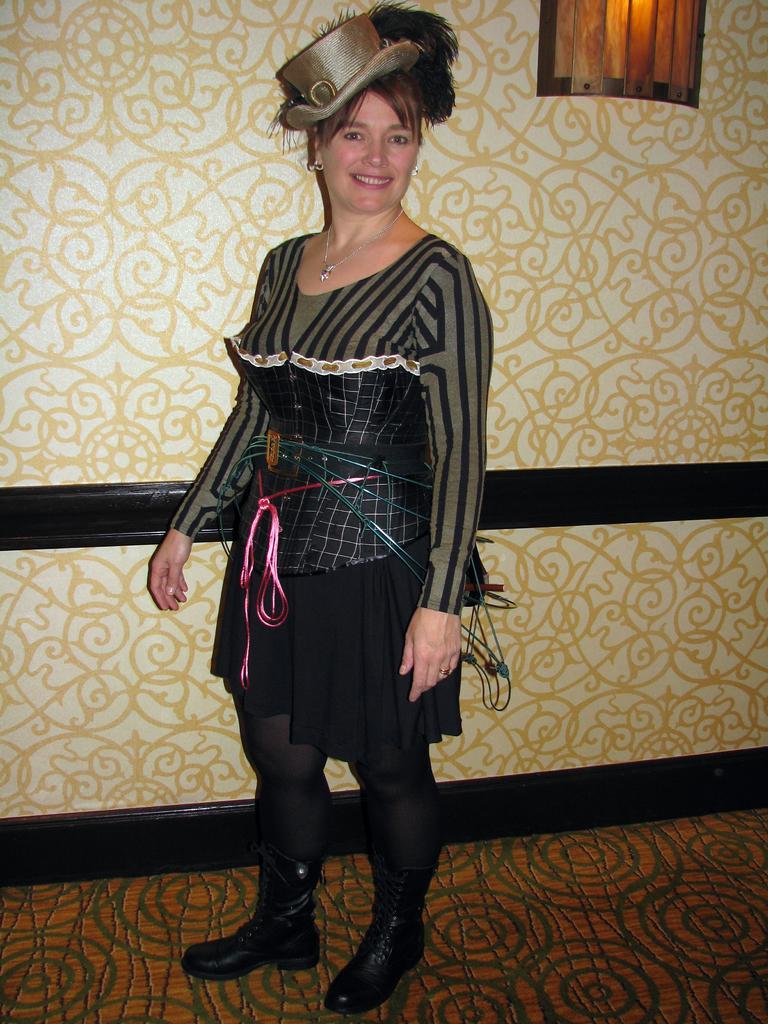In one or two sentences, can you explain what this image depicts? In this image we can see a woman standing and smiling, in the background, we can see the wall with some design and also we can see a window. 